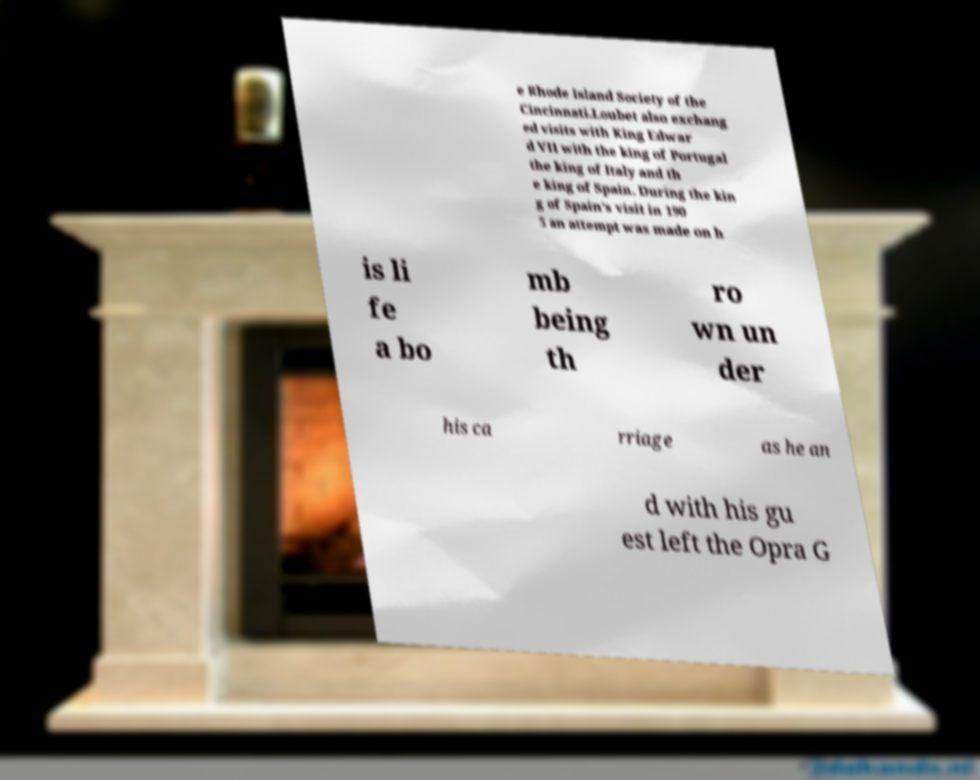Please identify and transcribe the text found in this image. e Rhode Island Society of the Cincinnati.Loubet also exchang ed visits with King Edwar d VII with the king of Portugal the king of Italy and th e king of Spain. During the kin g of Spain's visit in 190 5 an attempt was made on h is li fe a bo mb being th ro wn un der his ca rriage as he an d with his gu est left the Opra G 